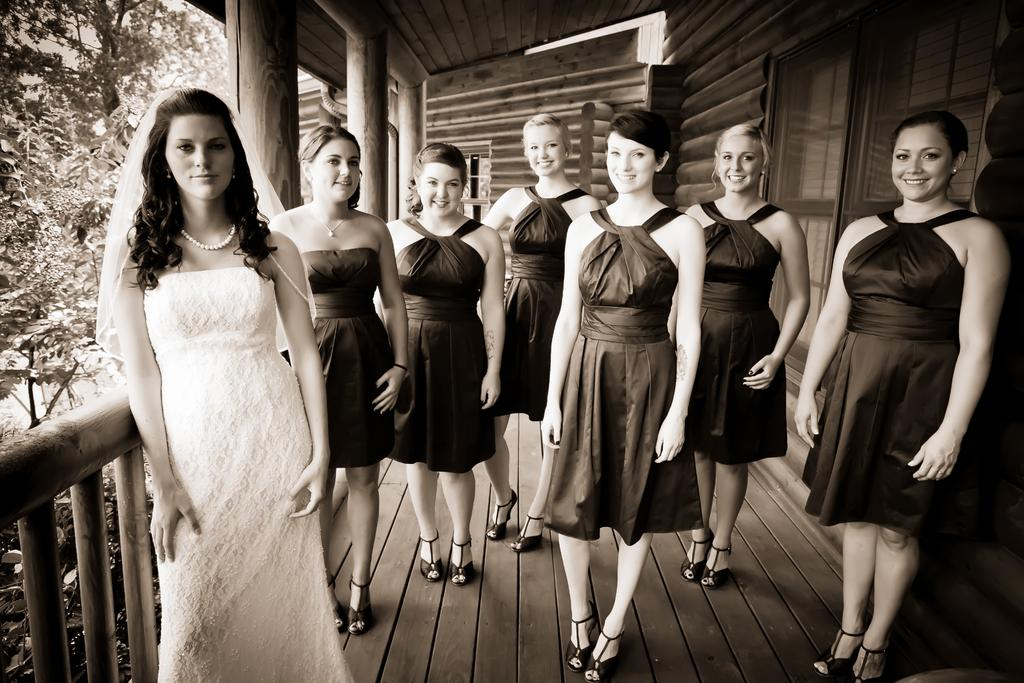How many women are in the foreground of the image? There are seven women standing in the foreground. Where are the women positioned in the image? The women are standing on the floor and fence. What can be seen in the background of the image? There is a door, pillars, trees, and a rooftop visible in the background. When was the image taken? The image was taken during the day. What type of reaction can be seen on the faces of the women in the image? There is no indication of any specific reaction on the faces of the women in the image. How many books are visible in the image? There are no books present in the image. 